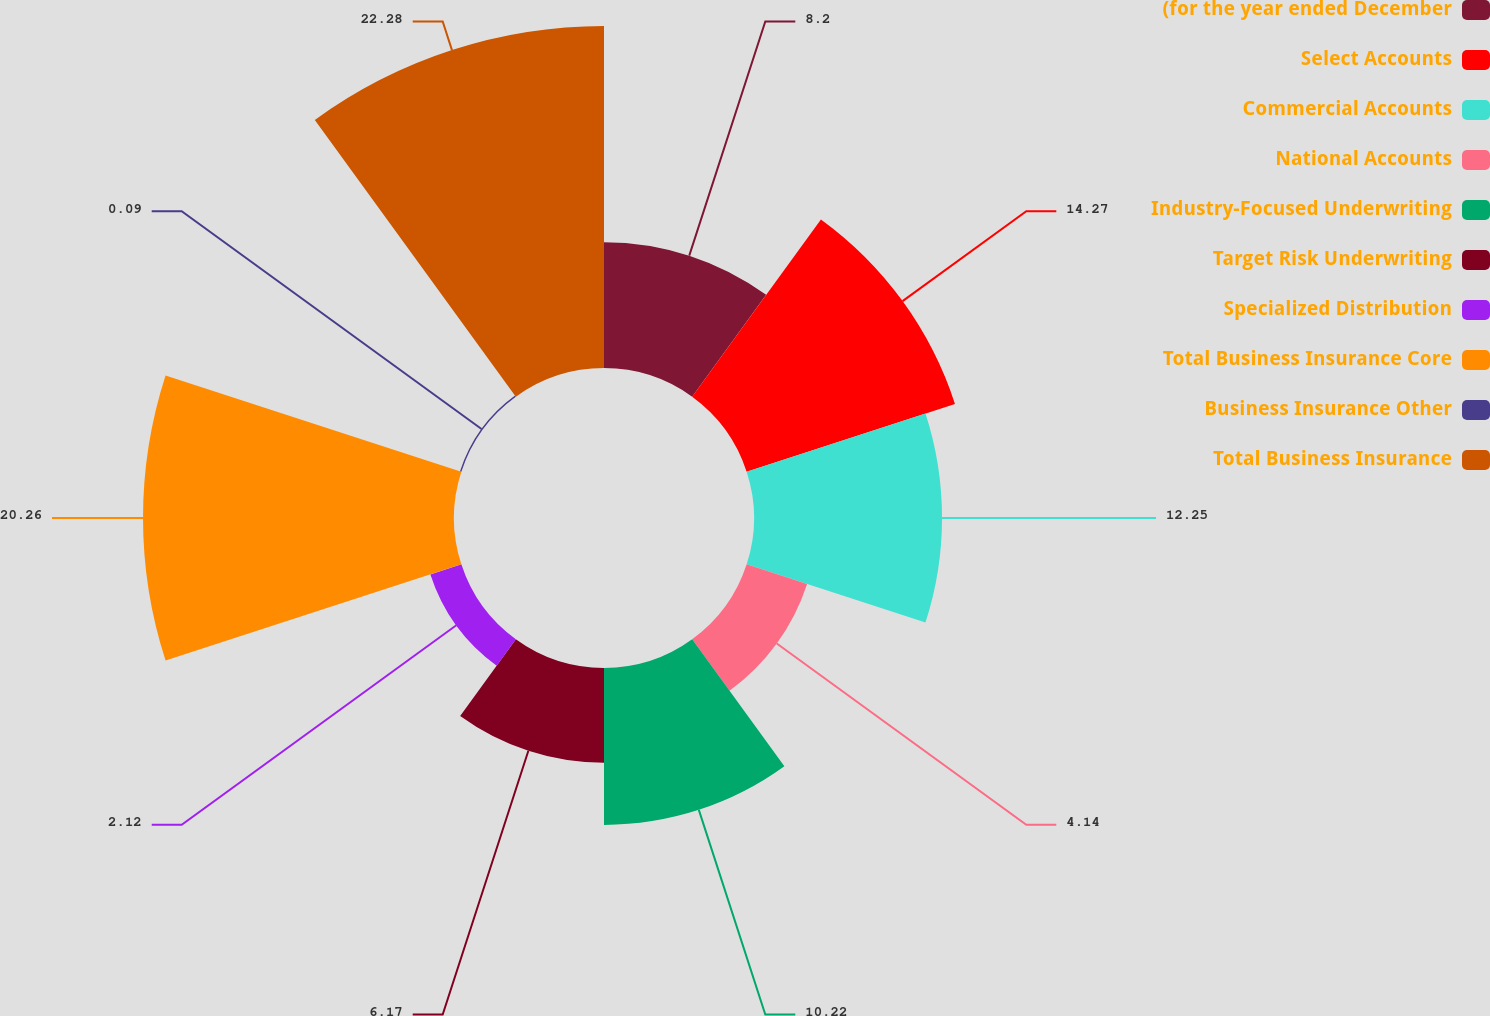Convert chart to OTSL. <chart><loc_0><loc_0><loc_500><loc_500><pie_chart><fcel>(for the year ended December<fcel>Select Accounts<fcel>Commercial Accounts<fcel>National Accounts<fcel>Industry-Focused Underwriting<fcel>Target Risk Underwriting<fcel>Specialized Distribution<fcel>Total Business Insurance Core<fcel>Business Insurance Other<fcel>Total Business Insurance<nl><fcel>8.2%<fcel>14.27%<fcel>12.25%<fcel>4.14%<fcel>10.22%<fcel>6.17%<fcel>2.12%<fcel>20.26%<fcel>0.09%<fcel>22.28%<nl></chart> 